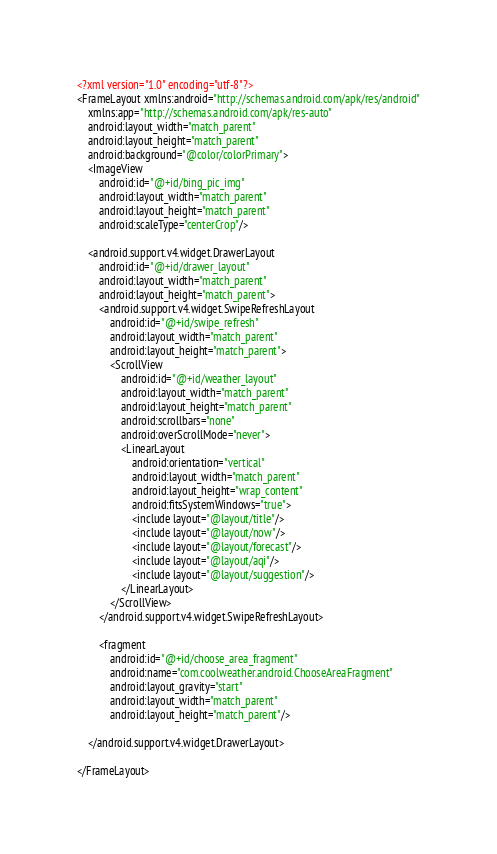Convert code to text. <code><loc_0><loc_0><loc_500><loc_500><_XML_><?xml version="1.0" encoding="utf-8"?>
<FrameLayout xmlns:android="http://schemas.android.com/apk/res/android"
    xmlns:app="http://schemas.android.com/apk/res-auto"
    android:layout_width="match_parent"
    android:layout_height="match_parent"
    android:background="@color/colorPrimary">
    <ImageView
        android:id="@+id/bing_pic_img"
        android:layout_width="match_parent"
        android:layout_height="match_parent"
        android:scaleType="centerCrop"/>

    <android.support.v4.widget.DrawerLayout
        android:id="@+id/drawer_layout"
        android:layout_width="match_parent"
        android:layout_height="match_parent">
        <android.support.v4.widget.SwipeRefreshLayout
            android:id="@+id/swipe_refresh"
            android:layout_width="match_parent"
            android:layout_height="match_parent">
            <ScrollView
                android:id="@+id/weather_layout"
                android:layout_width="match_parent"
                android:layout_height="match_parent"
                android:scrollbars="none"
                android:overScrollMode="never">
                <LinearLayout
                    android:orientation="vertical"
                    android:layout_width="match_parent"
                    android:layout_height="wrap_content"
                    android:fitsSystemWindows="true">
                    <include layout="@layout/title"/>
                    <include layout="@layout/now"/>
                    <include layout="@layout/forecast"/>
                    <include layout="@layout/aqi"/>
                    <include layout="@layout/suggestion"/>
                </LinearLayout>
            </ScrollView>
        </android.support.v4.widget.SwipeRefreshLayout>

        <fragment
            android:id="@+id/choose_area_fragment"
            android:name="com.coolweather.android.ChooseAreaFragment"
            android:layout_gravity="start"
            android:layout_width="match_parent"
            android:layout_height="match_parent"/>

    </android.support.v4.widget.DrawerLayout>

</FrameLayout>
</code> 